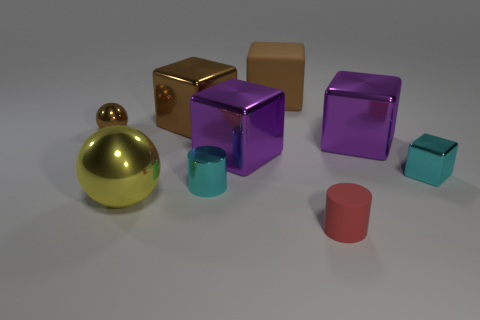Is the rubber block the same color as the tiny ball?
Your answer should be compact. Yes. Are there any other things that are the same color as the small metal cube?
Provide a short and direct response. Yes. Are the cyan object that is behind the shiny cylinder and the tiny cylinder in front of the big yellow object made of the same material?
Keep it short and to the point. No. There is a large metal thing that is the same color as the big rubber thing; what is its shape?
Provide a succinct answer. Cube. How many things are metallic balls that are to the left of the large yellow object or purple metal blocks right of the small red cylinder?
Give a very brief answer. 2. Does the small metallic thing that is left of the tiny cyan cylinder have the same color as the rubber thing behind the big yellow ball?
Your answer should be compact. Yes. There is a thing that is both right of the small metallic cylinder and in front of the small cyan metallic cylinder; what is its shape?
Offer a very short reply. Cylinder. What color is the matte object that is the same size as the yellow metallic ball?
Provide a succinct answer. Brown. Is there a shiny thing of the same color as the tiny cube?
Keep it short and to the point. Yes. There is a cyan shiny thing right of the tiny red cylinder; does it have the same size as the ball in front of the small cyan block?
Your response must be concise. No. 